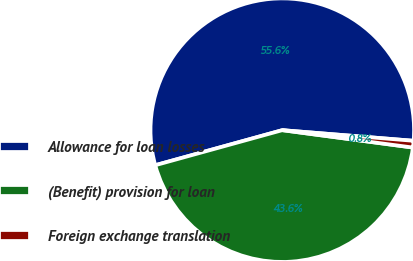Convert chart to OTSL. <chart><loc_0><loc_0><loc_500><loc_500><pie_chart><fcel>Allowance for loan losses<fcel>(Benefit) provision for loan<fcel>Foreign exchange translation<nl><fcel>55.57%<fcel>43.61%<fcel>0.82%<nl></chart> 